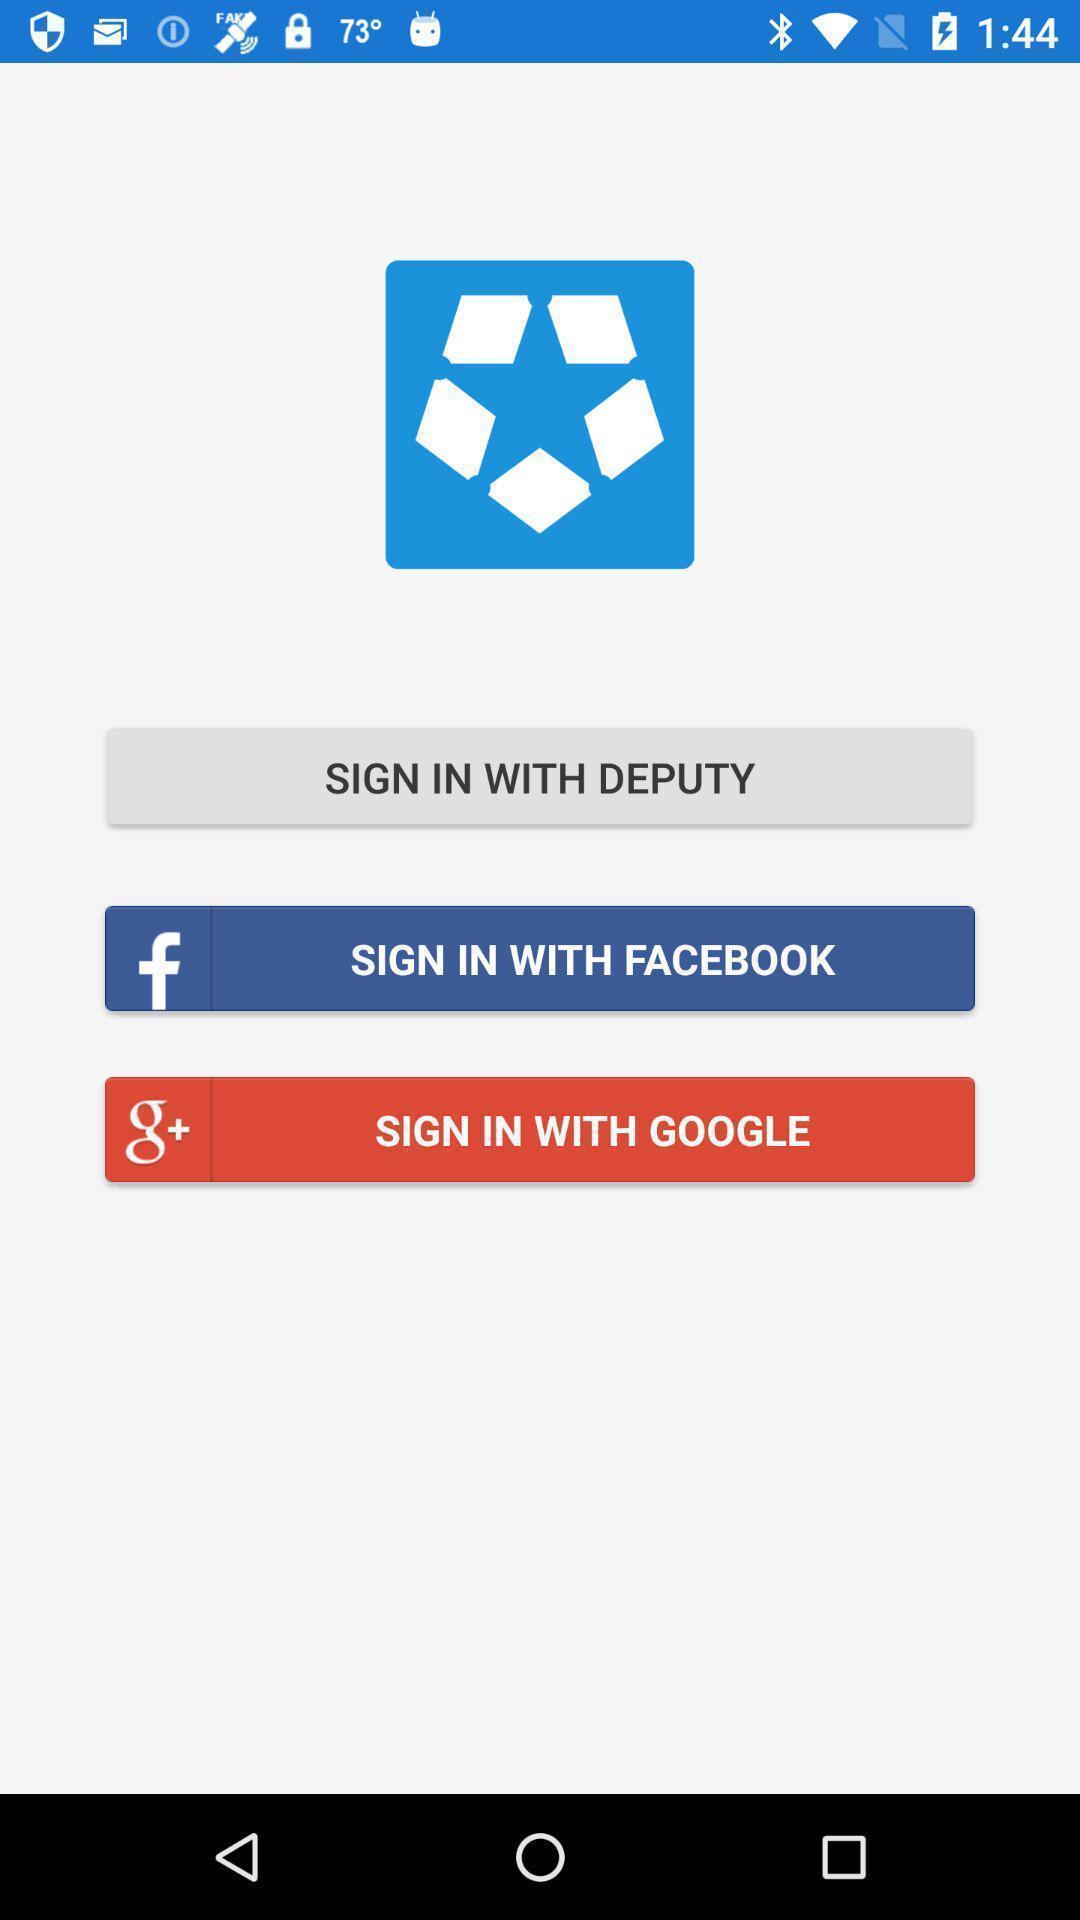Tell me what you see in this picture. Sign in page of an social app. 